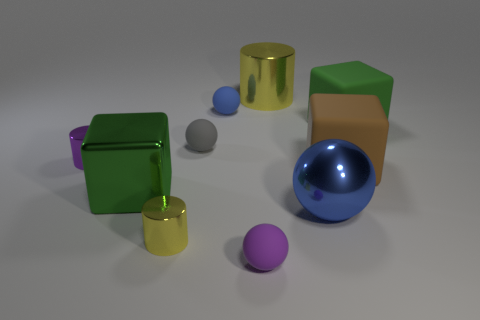Is the color of the large ball the same as the tiny metal cylinder that is behind the tiny yellow metallic cylinder?
Ensure brevity in your answer.  No. There is a matte ball in front of the big blue object right of the small purple metallic cylinder; what color is it?
Your answer should be very brief. Purple. Is there anything else that has the same size as the purple matte ball?
Provide a short and direct response. Yes. Is the shape of the tiny metallic object that is on the left side of the tiny yellow cylinder the same as  the large green rubber object?
Give a very brief answer. No. What number of objects are in front of the purple cylinder and right of the tiny blue thing?
Your response must be concise. 3. There is a large rubber cube on the left side of the green block right of the large green block that is in front of the big brown rubber block; what is its color?
Give a very brief answer. Brown. What number of big yellow shiny cylinders are in front of the yellow object that is on the right side of the blue rubber object?
Ensure brevity in your answer.  0. What number of other objects are there of the same shape as the small yellow thing?
Your answer should be very brief. 2. How many objects are small cyan spheres or cubes that are in front of the large green matte cube?
Provide a short and direct response. 2. Is the number of tiny purple objects that are left of the blue metallic object greater than the number of large brown matte cubes that are right of the brown cube?
Give a very brief answer. Yes. 